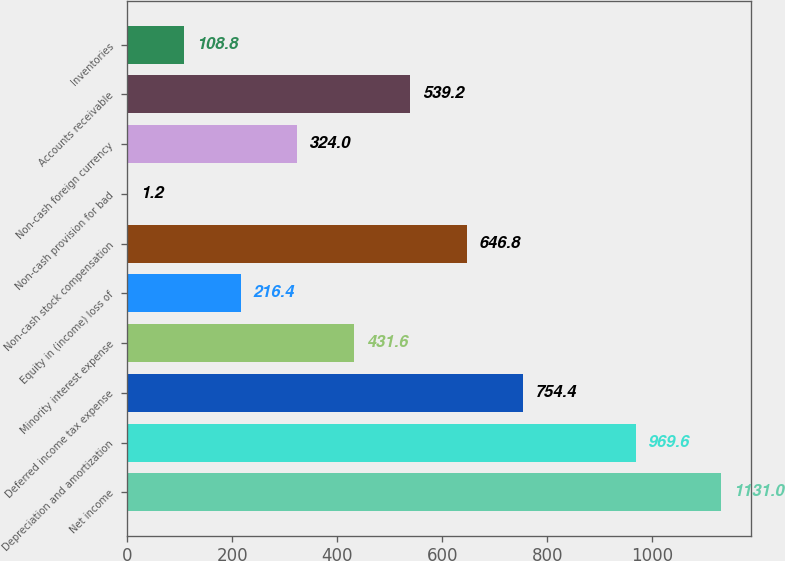Convert chart to OTSL. <chart><loc_0><loc_0><loc_500><loc_500><bar_chart><fcel>Net income<fcel>Depreciation and amortization<fcel>Deferred income tax expense<fcel>Minority interest expense<fcel>Equity in (income) loss of<fcel>Non-cash stock compensation<fcel>Non-cash provision for bad<fcel>Non-cash foreign currency<fcel>Accounts receivable<fcel>Inventories<nl><fcel>1131<fcel>969.6<fcel>754.4<fcel>431.6<fcel>216.4<fcel>646.8<fcel>1.2<fcel>324<fcel>539.2<fcel>108.8<nl></chart> 